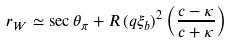Convert formula to latex. <formula><loc_0><loc_0><loc_500><loc_500>r _ { W } \simeq \sec \theta _ { \pi } + R \, ( q \xi _ { b } ) ^ { 2 } \left ( \frac { c - \kappa } { c + \kappa } \right )</formula> 